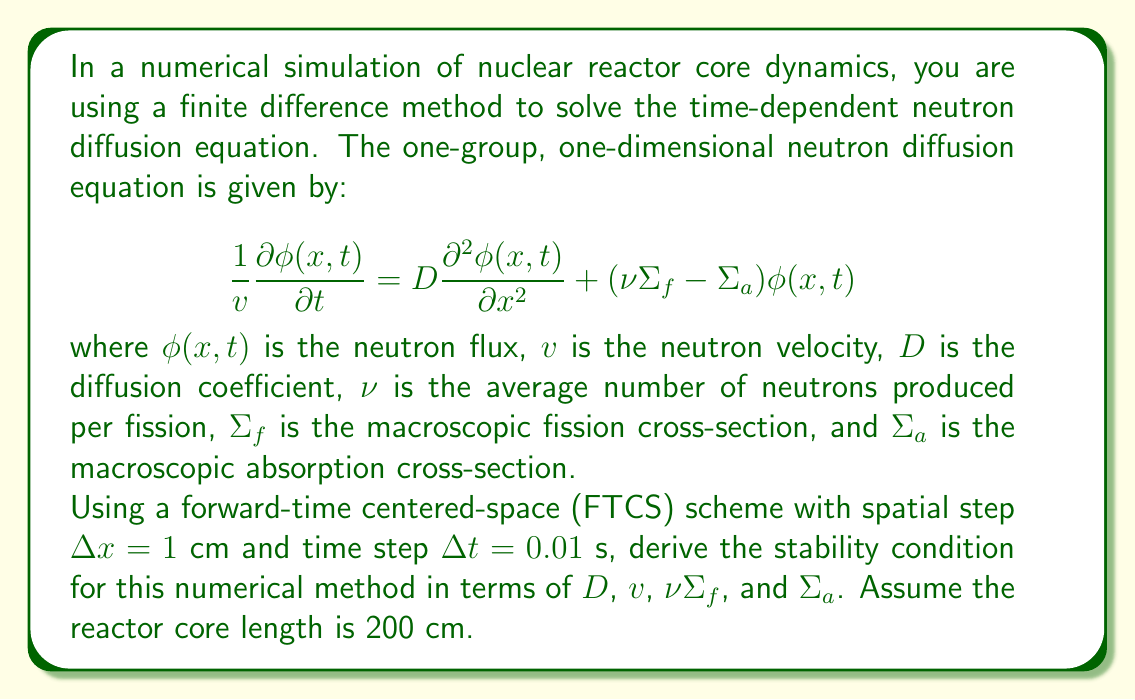Show me your answer to this math problem. To derive the stability condition for the FTCS scheme applied to the neutron diffusion equation, we follow these steps:

1) First, we discretize the equation using the FTCS scheme:

   $$\frac{\phi_{i}^{n+1} - \phi_{i}^n}{v\Delta t} = D\frac{\phi_{i+1}^n - 2\phi_{i}^n + \phi_{i-1}^n}{(\Delta x)^2} + (\nu\Sigma_f - \Sigma_a)\phi_{i}^n$$

2) Rearrange the equation to isolate $\phi_{i}^{n+1}$:

   $$\phi_{i}^{n+1} = \phi_{i}^n + \frac{D v \Delta t}{(\Delta x)^2}(\phi_{i+1}^n - 2\phi_{i}^n + \phi_{i-1}^n) + v\Delta t(\nu\Sigma_f - \Sigma_a)\phi_{i}^n$$

3) For stability, we require that the absolute value of the coefficients of $\phi_{i}^n$, $\phi_{i+1}^n$, and $\phi_{i-1}^n$ sum to less than or equal to 1:

   $$\left|1 - \frac{2D v \Delta t}{(\Delta x)^2} + v\Delta t(\nu\Sigma_f - \Sigma_a)\right| + 2\left|\frac{D v \Delta t}{(\Delta x)^2}\right| \leq 1$$

4) Simplify by substituting the given values $\Delta x = 1$ cm and $\Delta t = 0.01$ s:

   $$\left|1 - 0.02Dv + 0.01v(\nu\Sigma_f - \Sigma_a)\right| + 0.02Dv \leq 1$$

5) For this inequality to hold, we need:

   $$0.02Dv - 0.01v(\nu\Sigma_f - \Sigma_a) \leq 1$$

6) Solving for $D$:

   $$D \leq \frac{50}{v} + \frac{1}{2}(\nu\Sigma_f - \Sigma_a)$$

This is the stability condition for the FTCS scheme applied to the neutron diffusion equation with the given parameters.
Answer: The stability condition for the FTCS scheme is:

$$D \leq \frac{50}{v} + \frac{1}{2}(\nu\Sigma_f - \Sigma_a)$$

where $D$ is the diffusion coefficient, $v$ is the neutron velocity, $\nu$ is the average number of neutrons produced per fission, $\Sigma_f$ is the macroscopic fission cross-section, and $\Sigma_a$ is the macroscopic absorption cross-section. 